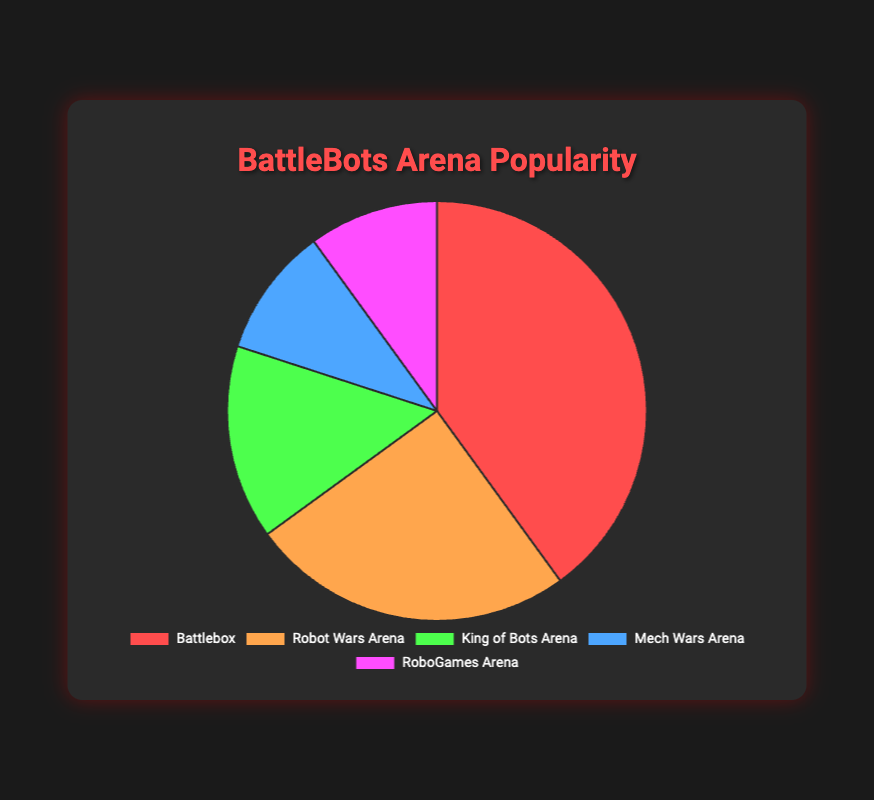What is the most popular arena? The pie chart shows that the Battlebox has the highest percentage slice. Hence, the most popular arena is the Battlebox.
Answer: Battlebox Which arena has the smallest share of popularity? The pie chart shows that both the Mech Wars Arena and RoboGames Arena have the smallest shares, each with 10%.
Answer: Mech Wars Arena and RoboGames Arena How much more popular is the Battlebox compared to the Robot Wars Arena? The Battlebox has 40% popularity, while the Robot Wars Arena has 25%. The difference is 40% - 25% = 15%.
Answer: 15% What is the combined popularity percentage for the King of Bots Arena, Mech Wars Arena, and RoboGames Arena? The King of Bots Arena has 15%, Mech Wars Arena has 10%, and RoboGames Arena has 10%. The sum is 15% + 10% + 10% = 35%.
Answer: 35% How does the popularity of Mech Wars Arena compare to RoboGames Arena? Both the Mech Wars Arena and RoboGames Arena have the same percentage of popularity, 10%.
Answer: They are equal What percentage of the total do the most and least popular arenas combine to make? The most popular is the Battlebox at 40%, and the least popular are Mech Wars Arena and RoboGames Arena, each at 10%. The total is 40% + 10% + 10% = 60%.
Answer: 60% Arrange the arenas in descending order of their popularity. The arenas are arranged as follows based on their percentages: Battlebox (40%), Robot Wars Arena (25%), King of Bots Arena (15%), Mech Wars Arena (10%), and RoboGames Arena (10%).
Answer: Battlebox, Robot Wars Arena, King of Bots Arena, Mech Wars Arena, RoboGames Arena What fraction of the total popularity does the Robot Wars Arena hold? The pie chart shows that Robot Wars Arena holds 25% of the total popularity. Therefore, the fraction is 25 out of 100, which simplifies to 1/4.
Answer: 1/4 Is the combined popularity of Robot Wars Arena and King of Bots Arena greater than Battlebox's popularity? Robot Wars Arena and King of Bots Arena together have 25% + 15% = 40%. Battlebox alone also has 40%, so combined they are exactly equal to Battlebox's popularity.
Answer: No 